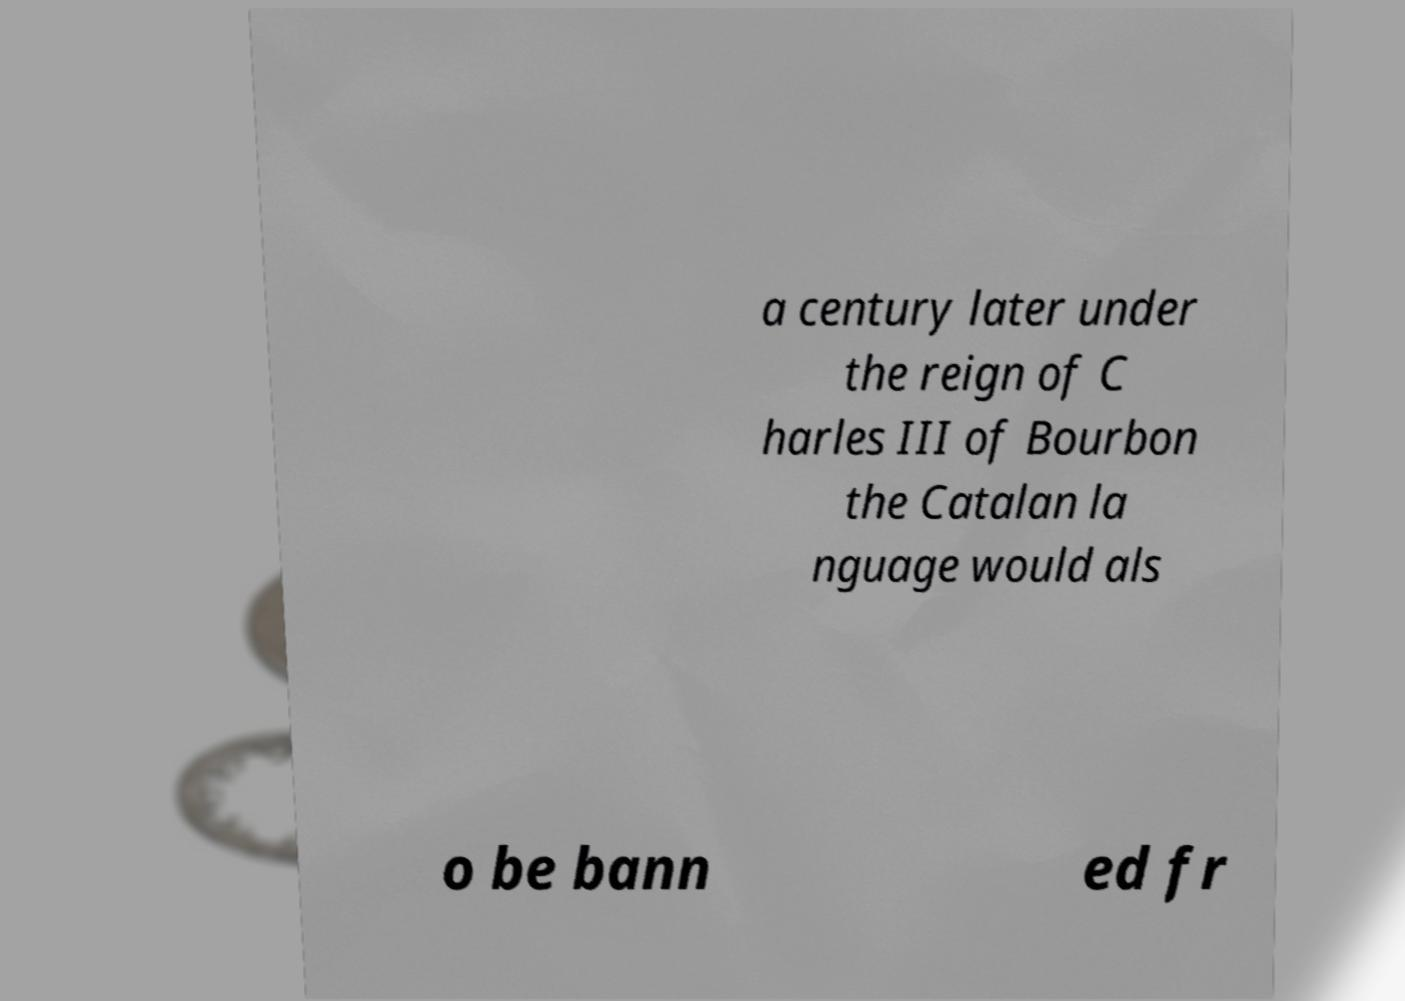Please read and relay the text visible in this image. What does it say? a century later under the reign of C harles III of Bourbon the Catalan la nguage would als o be bann ed fr 